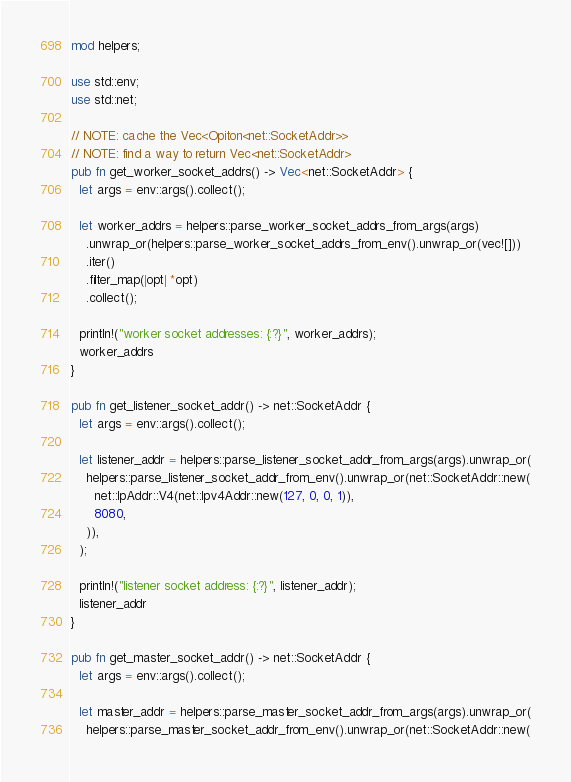<code> <loc_0><loc_0><loc_500><loc_500><_Rust_>mod helpers;

use std::env;
use std::net;

// NOTE: cache the Vec<Opiton<net::SocketAddr>>
// NOTE: find a way to return Vec<net::SocketAddr>
pub fn get_worker_socket_addrs() -> Vec<net::SocketAddr> {
  let args = env::args().collect();

  let worker_addrs = helpers::parse_worker_socket_addrs_from_args(args)
    .unwrap_or(helpers::parse_worker_socket_addrs_from_env().unwrap_or(vec![]))
    .iter()
    .filter_map(|opt| *opt)
    .collect();

  println!("worker socket addresses: {:?}", worker_addrs);
  worker_addrs
}

pub fn get_listener_socket_addr() -> net::SocketAddr {
  let args = env::args().collect();

  let listener_addr = helpers::parse_listener_socket_addr_from_args(args).unwrap_or(
    helpers::parse_listener_socket_addr_from_env().unwrap_or(net::SocketAddr::new(
      net::IpAddr::V4(net::Ipv4Addr::new(127, 0, 0, 1)),
      8080,
    )),
  );

  println!("listener socket address: {:?}", listener_addr);
  listener_addr
}

pub fn get_master_socket_addr() -> net::SocketAddr {
  let args = env::args().collect();

  let master_addr = helpers::parse_master_socket_addr_from_args(args).unwrap_or(
    helpers::parse_master_socket_addr_from_env().unwrap_or(net::SocketAddr::new(</code> 